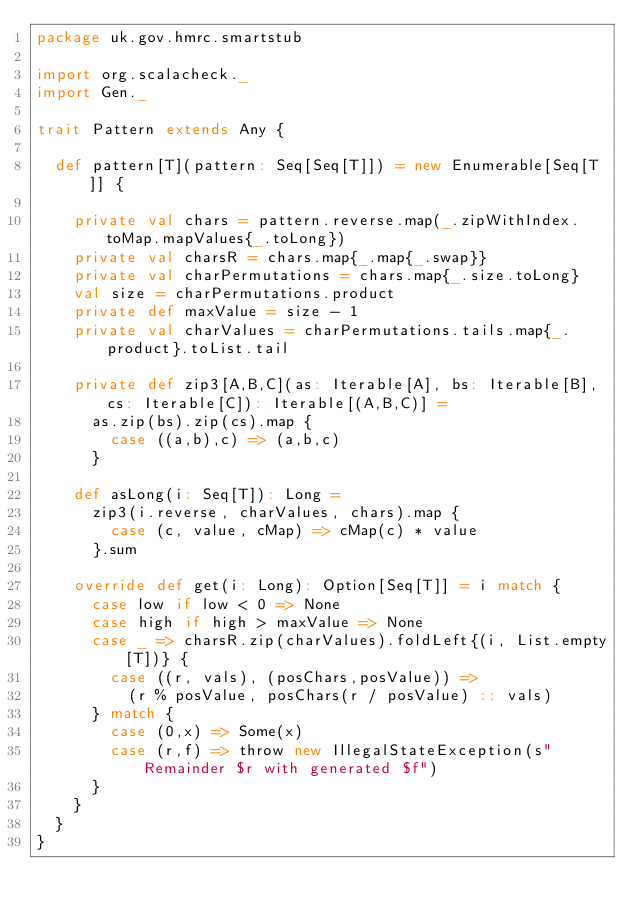<code> <loc_0><loc_0><loc_500><loc_500><_Scala_>package uk.gov.hmrc.smartstub

import org.scalacheck._
import Gen._

trait Pattern extends Any {

  def pattern[T](pattern: Seq[Seq[T]]) = new Enumerable[Seq[T]] {

    private val chars = pattern.reverse.map(_.zipWithIndex.toMap.mapValues{_.toLong})
    private val charsR = chars.map{_.map{_.swap}}
    private val charPermutations = chars.map{_.size.toLong}
    val size = charPermutations.product
    private def maxValue = size - 1
    private val charValues = charPermutations.tails.map{_.product}.toList.tail

    private def zip3[A,B,C](as: Iterable[A], bs: Iterable[B], cs: Iterable[C]): Iterable[(A,B,C)] =
      as.zip(bs).zip(cs).map {
        case ((a,b),c) => (a,b,c)
      }

    def asLong(i: Seq[T]): Long =
      zip3(i.reverse, charValues, chars).map {
        case (c, value, cMap) => cMap(c) * value
      }.sum

    override def get(i: Long): Option[Seq[T]] = i match {
      case low if low < 0 => None
      case high if high > maxValue => None
      case _ => charsR.zip(charValues).foldLeft{(i, List.empty[T])} {
        case ((r, vals), (posChars,posValue)) =>
          (r % posValue, posChars(r / posValue) :: vals)
      } match {
        case (0,x) => Some(x)
        case (r,f) => throw new IllegalStateException(s"Remainder $r with generated $f")
      }
    }      
  }  
}
</code> 